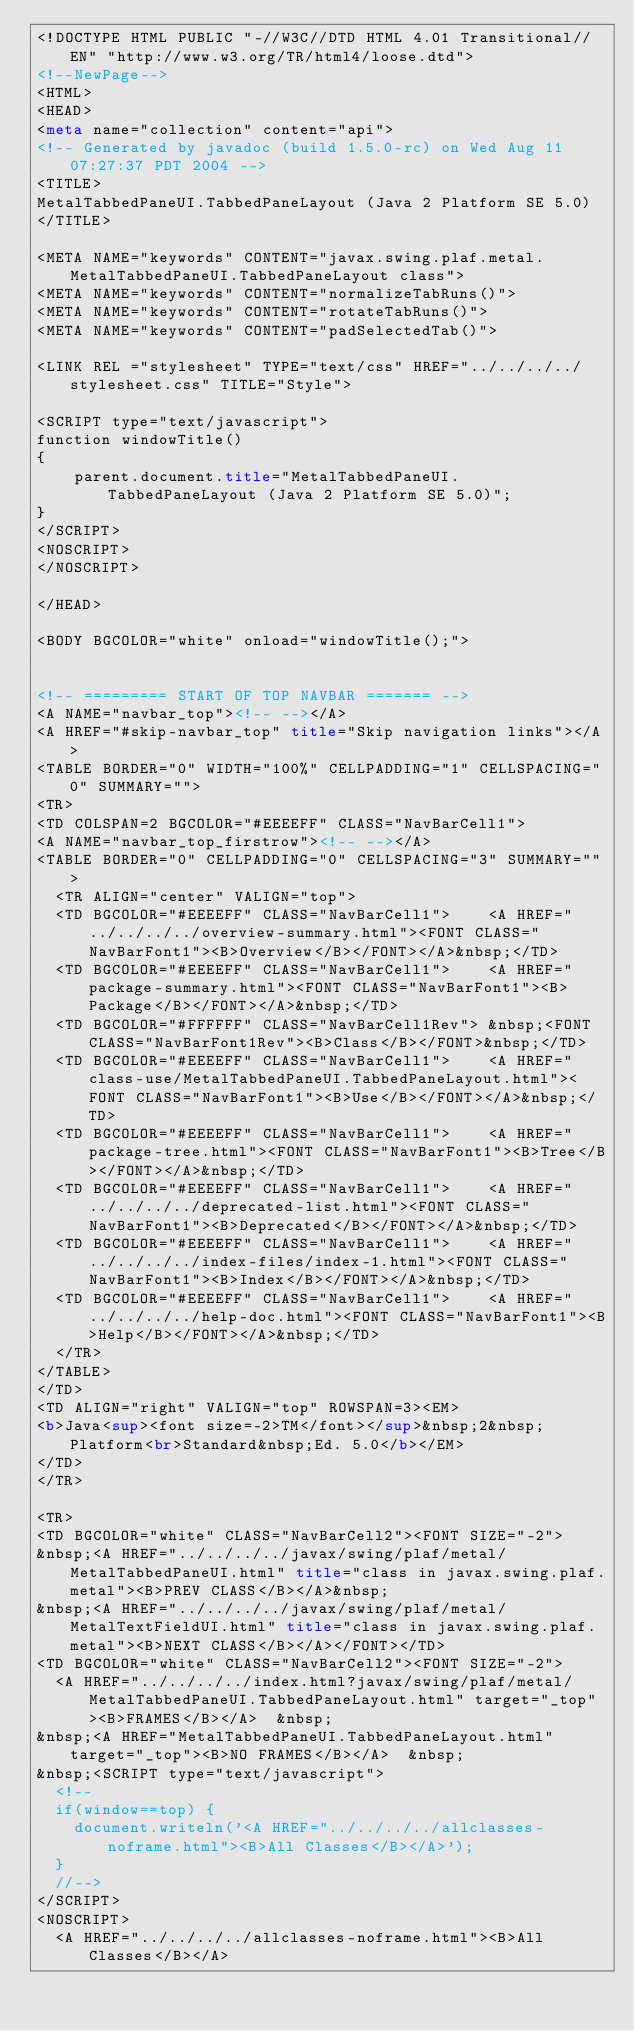<code> <loc_0><loc_0><loc_500><loc_500><_HTML_><!DOCTYPE HTML PUBLIC "-//W3C//DTD HTML 4.01 Transitional//EN" "http://www.w3.org/TR/html4/loose.dtd">
<!--NewPage-->
<HTML>
<HEAD>
<meta name="collection" content="api">
<!-- Generated by javadoc (build 1.5.0-rc) on Wed Aug 11 07:27:37 PDT 2004 -->
<TITLE>
MetalTabbedPaneUI.TabbedPaneLayout (Java 2 Platform SE 5.0)
</TITLE>

<META NAME="keywords" CONTENT="javax.swing.plaf.metal.MetalTabbedPaneUI.TabbedPaneLayout class">
<META NAME="keywords" CONTENT="normalizeTabRuns()">
<META NAME="keywords" CONTENT="rotateTabRuns()">
<META NAME="keywords" CONTENT="padSelectedTab()">

<LINK REL ="stylesheet" TYPE="text/css" HREF="../../../../stylesheet.css" TITLE="Style">

<SCRIPT type="text/javascript">
function windowTitle()
{
    parent.document.title="MetalTabbedPaneUI.TabbedPaneLayout (Java 2 Platform SE 5.0)";
}
</SCRIPT>
<NOSCRIPT>
</NOSCRIPT>

</HEAD>

<BODY BGCOLOR="white" onload="windowTitle();">


<!-- ========= START OF TOP NAVBAR ======= -->
<A NAME="navbar_top"><!-- --></A>
<A HREF="#skip-navbar_top" title="Skip navigation links"></A>
<TABLE BORDER="0" WIDTH="100%" CELLPADDING="1" CELLSPACING="0" SUMMARY="">
<TR>
<TD COLSPAN=2 BGCOLOR="#EEEEFF" CLASS="NavBarCell1">
<A NAME="navbar_top_firstrow"><!-- --></A>
<TABLE BORDER="0" CELLPADDING="0" CELLSPACING="3" SUMMARY="">
  <TR ALIGN="center" VALIGN="top">
  <TD BGCOLOR="#EEEEFF" CLASS="NavBarCell1">    <A HREF="../../../../overview-summary.html"><FONT CLASS="NavBarFont1"><B>Overview</B></FONT></A>&nbsp;</TD>
  <TD BGCOLOR="#EEEEFF" CLASS="NavBarCell1">    <A HREF="package-summary.html"><FONT CLASS="NavBarFont1"><B>Package</B></FONT></A>&nbsp;</TD>
  <TD BGCOLOR="#FFFFFF" CLASS="NavBarCell1Rev"> &nbsp;<FONT CLASS="NavBarFont1Rev"><B>Class</B></FONT>&nbsp;</TD>
  <TD BGCOLOR="#EEEEFF" CLASS="NavBarCell1">    <A HREF="class-use/MetalTabbedPaneUI.TabbedPaneLayout.html"><FONT CLASS="NavBarFont1"><B>Use</B></FONT></A>&nbsp;</TD>
  <TD BGCOLOR="#EEEEFF" CLASS="NavBarCell1">    <A HREF="package-tree.html"><FONT CLASS="NavBarFont1"><B>Tree</B></FONT></A>&nbsp;</TD>
  <TD BGCOLOR="#EEEEFF" CLASS="NavBarCell1">    <A HREF="../../../../deprecated-list.html"><FONT CLASS="NavBarFont1"><B>Deprecated</B></FONT></A>&nbsp;</TD>
  <TD BGCOLOR="#EEEEFF" CLASS="NavBarCell1">    <A HREF="../../../../index-files/index-1.html"><FONT CLASS="NavBarFont1"><B>Index</B></FONT></A>&nbsp;</TD>
  <TD BGCOLOR="#EEEEFF" CLASS="NavBarCell1">    <A HREF="../../../../help-doc.html"><FONT CLASS="NavBarFont1"><B>Help</B></FONT></A>&nbsp;</TD>
  </TR>
</TABLE>
</TD>
<TD ALIGN="right" VALIGN="top" ROWSPAN=3><EM>
<b>Java<sup><font size=-2>TM</font></sup>&nbsp;2&nbsp;Platform<br>Standard&nbsp;Ed. 5.0</b></EM>
</TD>
</TR>

<TR>
<TD BGCOLOR="white" CLASS="NavBarCell2"><FONT SIZE="-2">
&nbsp;<A HREF="../../../../javax/swing/plaf/metal/MetalTabbedPaneUI.html" title="class in javax.swing.plaf.metal"><B>PREV CLASS</B></A>&nbsp;
&nbsp;<A HREF="../../../../javax/swing/plaf/metal/MetalTextFieldUI.html" title="class in javax.swing.plaf.metal"><B>NEXT CLASS</B></A></FONT></TD>
<TD BGCOLOR="white" CLASS="NavBarCell2"><FONT SIZE="-2">
  <A HREF="../../../../index.html?javax/swing/plaf/metal/MetalTabbedPaneUI.TabbedPaneLayout.html" target="_top"><B>FRAMES</B></A>  &nbsp;
&nbsp;<A HREF="MetalTabbedPaneUI.TabbedPaneLayout.html" target="_top"><B>NO FRAMES</B></A>  &nbsp;
&nbsp;<SCRIPT type="text/javascript">
  <!--
  if(window==top) {
    document.writeln('<A HREF="../../../../allclasses-noframe.html"><B>All Classes</B></A>');
  }
  //-->
</SCRIPT>
<NOSCRIPT>
  <A HREF="../../../../allclasses-noframe.html"><B>All Classes</B></A></code> 